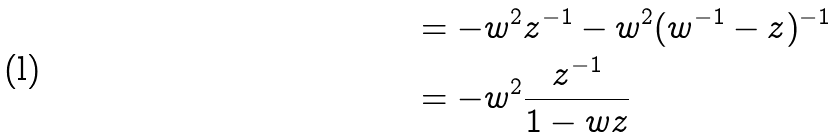Convert formula to latex. <formula><loc_0><loc_0><loc_500><loc_500>& = - w ^ { 2 } z ^ { - 1 } - w ^ { 2 } ( w ^ { - 1 } - z ) ^ { - 1 } \\ & = - w ^ { 2 } \frac { z ^ { - 1 } } { 1 - w z }</formula> 